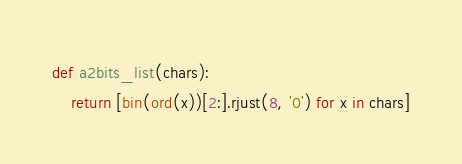<code> <loc_0><loc_0><loc_500><loc_500><_Python_>def a2bits_list(chars):
	return [bin(ord(x))[2:].rjust(8, '0') for x in chars]</code> 